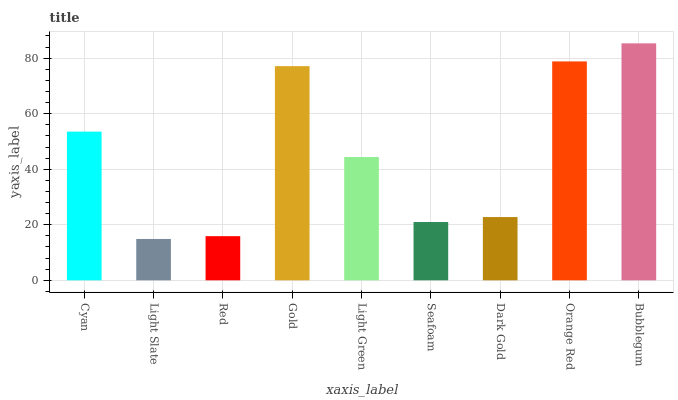Is Light Slate the minimum?
Answer yes or no. Yes. Is Bubblegum the maximum?
Answer yes or no. Yes. Is Red the minimum?
Answer yes or no. No. Is Red the maximum?
Answer yes or no. No. Is Red greater than Light Slate?
Answer yes or no. Yes. Is Light Slate less than Red?
Answer yes or no. Yes. Is Light Slate greater than Red?
Answer yes or no. No. Is Red less than Light Slate?
Answer yes or no. No. Is Light Green the high median?
Answer yes or no. Yes. Is Light Green the low median?
Answer yes or no. Yes. Is Gold the high median?
Answer yes or no. No. Is Gold the low median?
Answer yes or no. No. 